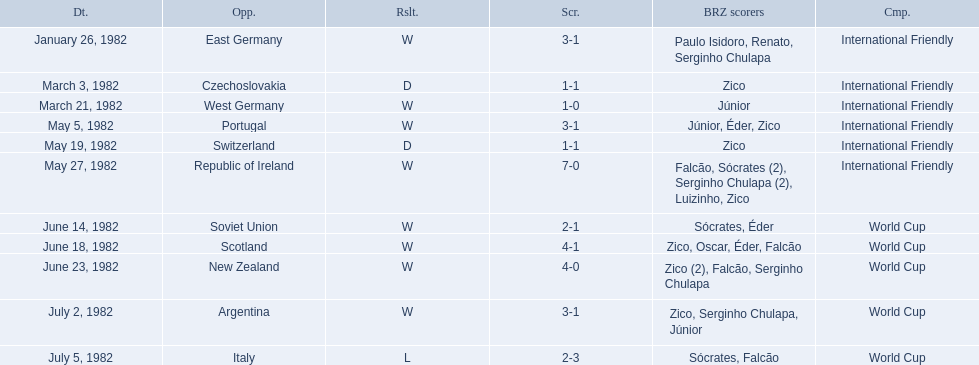How many goals did brazil score against the soviet union? 2-1. How many goals did brazil score against portugal? 3-1. Did brazil score more goals against portugal or the soviet union? Portugal. 